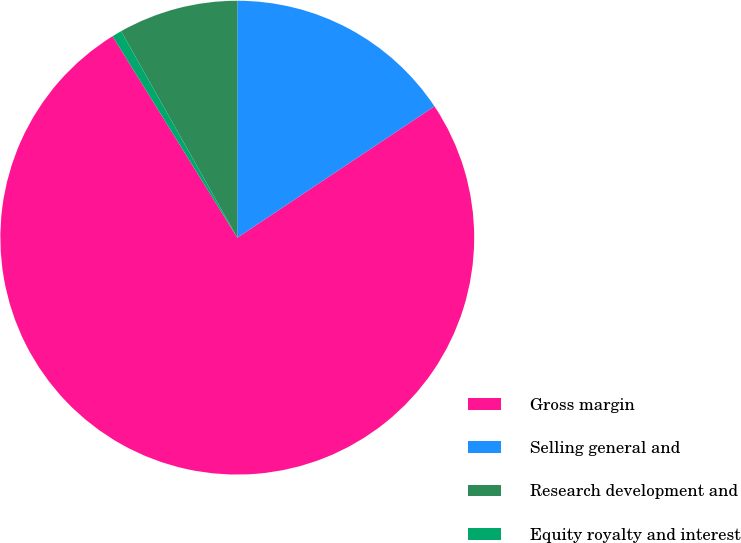Convert chart to OTSL. <chart><loc_0><loc_0><loc_500><loc_500><pie_chart><fcel>Gross margin<fcel>Selling general and<fcel>Research development and<fcel>Equity royalty and interest<nl><fcel>75.52%<fcel>15.64%<fcel>8.16%<fcel>0.67%<nl></chart> 